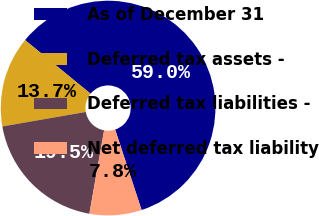Convert chart to OTSL. <chart><loc_0><loc_0><loc_500><loc_500><pie_chart><fcel>As of December 31<fcel>Deferred tax assets -<fcel>Deferred tax liabilities -<fcel>Net deferred tax liability<nl><fcel>59.03%<fcel>13.66%<fcel>19.47%<fcel>7.84%<nl></chart> 